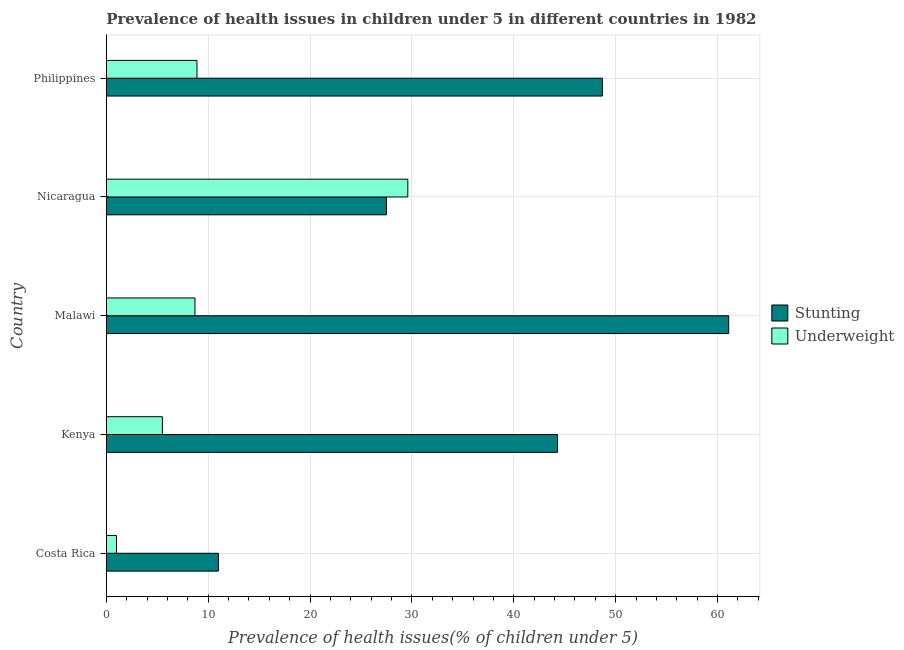How many different coloured bars are there?
Your answer should be very brief. 2. How many groups of bars are there?
Give a very brief answer. 5. Are the number of bars per tick equal to the number of legend labels?
Provide a succinct answer. Yes. Are the number of bars on each tick of the Y-axis equal?
Provide a succinct answer. Yes. How many bars are there on the 5th tick from the top?
Offer a very short reply. 2. What is the label of the 1st group of bars from the top?
Keep it short and to the point. Philippines. In how many cases, is the number of bars for a given country not equal to the number of legend labels?
Your answer should be very brief. 0. What is the percentage of stunted children in Philippines?
Provide a short and direct response. 48.7. Across all countries, what is the maximum percentage of stunted children?
Give a very brief answer. 61.1. In which country was the percentage of stunted children maximum?
Provide a short and direct response. Malawi. What is the total percentage of underweight children in the graph?
Give a very brief answer. 53.7. What is the difference between the percentage of underweight children in Costa Rica and that in Nicaragua?
Your response must be concise. -28.6. What is the average percentage of stunted children per country?
Give a very brief answer. 38.52. What is the difference between the percentage of stunted children and percentage of underweight children in Costa Rica?
Provide a succinct answer. 10. In how many countries, is the percentage of underweight children greater than 10 %?
Provide a short and direct response. 1. What is the ratio of the percentage of underweight children in Malawi to that in Nicaragua?
Provide a short and direct response. 0.29. Is the percentage of stunted children in Costa Rica less than that in Malawi?
Your answer should be very brief. Yes. What is the difference between the highest and the second highest percentage of stunted children?
Make the answer very short. 12.4. What is the difference between the highest and the lowest percentage of stunted children?
Provide a short and direct response. 50.1. Is the sum of the percentage of stunted children in Malawi and Philippines greater than the maximum percentage of underweight children across all countries?
Make the answer very short. Yes. What does the 1st bar from the top in Costa Rica represents?
Provide a succinct answer. Underweight. What does the 1st bar from the bottom in Philippines represents?
Offer a very short reply. Stunting. What is the difference between two consecutive major ticks on the X-axis?
Provide a succinct answer. 10. Are the values on the major ticks of X-axis written in scientific E-notation?
Keep it short and to the point. No. How many legend labels are there?
Make the answer very short. 2. How are the legend labels stacked?
Ensure brevity in your answer.  Vertical. What is the title of the graph?
Make the answer very short. Prevalence of health issues in children under 5 in different countries in 1982. What is the label or title of the X-axis?
Offer a very short reply. Prevalence of health issues(% of children under 5). What is the Prevalence of health issues(% of children under 5) in Stunting in Costa Rica?
Your response must be concise. 11. What is the Prevalence of health issues(% of children under 5) in Stunting in Kenya?
Your answer should be very brief. 44.3. What is the Prevalence of health issues(% of children under 5) of Underweight in Kenya?
Offer a terse response. 5.5. What is the Prevalence of health issues(% of children under 5) of Stunting in Malawi?
Ensure brevity in your answer.  61.1. What is the Prevalence of health issues(% of children under 5) in Underweight in Malawi?
Your answer should be very brief. 8.7. What is the Prevalence of health issues(% of children under 5) in Underweight in Nicaragua?
Keep it short and to the point. 29.6. What is the Prevalence of health issues(% of children under 5) in Stunting in Philippines?
Make the answer very short. 48.7. What is the Prevalence of health issues(% of children under 5) of Underweight in Philippines?
Give a very brief answer. 8.9. Across all countries, what is the maximum Prevalence of health issues(% of children under 5) in Stunting?
Ensure brevity in your answer.  61.1. Across all countries, what is the maximum Prevalence of health issues(% of children under 5) of Underweight?
Offer a terse response. 29.6. Across all countries, what is the minimum Prevalence of health issues(% of children under 5) of Stunting?
Your response must be concise. 11. What is the total Prevalence of health issues(% of children under 5) of Stunting in the graph?
Offer a very short reply. 192.6. What is the total Prevalence of health issues(% of children under 5) of Underweight in the graph?
Provide a short and direct response. 53.7. What is the difference between the Prevalence of health issues(% of children under 5) in Stunting in Costa Rica and that in Kenya?
Your answer should be compact. -33.3. What is the difference between the Prevalence of health issues(% of children under 5) in Stunting in Costa Rica and that in Malawi?
Your answer should be compact. -50.1. What is the difference between the Prevalence of health issues(% of children under 5) of Underweight in Costa Rica and that in Malawi?
Provide a succinct answer. -7.7. What is the difference between the Prevalence of health issues(% of children under 5) in Stunting in Costa Rica and that in Nicaragua?
Your response must be concise. -16.5. What is the difference between the Prevalence of health issues(% of children under 5) of Underweight in Costa Rica and that in Nicaragua?
Provide a short and direct response. -28.6. What is the difference between the Prevalence of health issues(% of children under 5) in Stunting in Costa Rica and that in Philippines?
Provide a succinct answer. -37.7. What is the difference between the Prevalence of health issues(% of children under 5) of Underweight in Costa Rica and that in Philippines?
Offer a terse response. -7.9. What is the difference between the Prevalence of health issues(% of children under 5) of Stunting in Kenya and that in Malawi?
Provide a succinct answer. -16.8. What is the difference between the Prevalence of health issues(% of children under 5) of Underweight in Kenya and that in Malawi?
Your response must be concise. -3.2. What is the difference between the Prevalence of health issues(% of children under 5) of Stunting in Kenya and that in Nicaragua?
Your response must be concise. 16.8. What is the difference between the Prevalence of health issues(% of children under 5) of Underweight in Kenya and that in Nicaragua?
Keep it short and to the point. -24.1. What is the difference between the Prevalence of health issues(% of children under 5) of Stunting in Malawi and that in Nicaragua?
Give a very brief answer. 33.6. What is the difference between the Prevalence of health issues(% of children under 5) in Underweight in Malawi and that in Nicaragua?
Offer a terse response. -20.9. What is the difference between the Prevalence of health issues(% of children under 5) in Stunting in Nicaragua and that in Philippines?
Give a very brief answer. -21.2. What is the difference between the Prevalence of health issues(% of children under 5) in Underweight in Nicaragua and that in Philippines?
Offer a terse response. 20.7. What is the difference between the Prevalence of health issues(% of children under 5) of Stunting in Costa Rica and the Prevalence of health issues(% of children under 5) of Underweight in Kenya?
Provide a short and direct response. 5.5. What is the difference between the Prevalence of health issues(% of children under 5) in Stunting in Costa Rica and the Prevalence of health issues(% of children under 5) in Underweight in Malawi?
Offer a terse response. 2.3. What is the difference between the Prevalence of health issues(% of children under 5) of Stunting in Costa Rica and the Prevalence of health issues(% of children under 5) of Underweight in Nicaragua?
Give a very brief answer. -18.6. What is the difference between the Prevalence of health issues(% of children under 5) of Stunting in Kenya and the Prevalence of health issues(% of children under 5) of Underweight in Malawi?
Keep it short and to the point. 35.6. What is the difference between the Prevalence of health issues(% of children under 5) in Stunting in Kenya and the Prevalence of health issues(% of children under 5) in Underweight in Nicaragua?
Offer a terse response. 14.7. What is the difference between the Prevalence of health issues(% of children under 5) in Stunting in Kenya and the Prevalence of health issues(% of children under 5) in Underweight in Philippines?
Your answer should be compact. 35.4. What is the difference between the Prevalence of health issues(% of children under 5) in Stunting in Malawi and the Prevalence of health issues(% of children under 5) in Underweight in Nicaragua?
Your response must be concise. 31.5. What is the difference between the Prevalence of health issues(% of children under 5) of Stunting in Malawi and the Prevalence of health issues(% of children under 5) of Underweight in Philippines?
Your response must be concise. 52.2. What is the difference between the Prevalence of health issues(% of children under 5) in Stunting in Nicaragua and the Prevalence of health issues(% of children under 5) in Underweight in Philippines?
Keep it short and to the point. 18.6. What is the average Prevalence of health issues(% of children under 5) of Stunting per country?
Keep it short and to the point. 38.52. What is the average Prevalence of health issues(% of children under 5) of Underweight per country?
Your answer should be very brief. 10.74. What is the difference between the Prevalence of health issues(% of children under 5) in Stunting and Prevalence of health issues(% of children under 5) in Underweight in Kenya?
Your response must be concise. 38.8. What is the difference between the Prevalence of health issues(% of children under 5) of Stunting and Prevalence of health issues(% of children under 5) of Underweight in Malawi?
Provide a short and direct response. 52.4. What is the difference between the Prevalence of health issues(% of children under 5) in Stunting and Prevalence of health issues(% of children under 5) in Underweight in Philippines?
Your response must be concise. 39.8. What is the ratio of the Prevalence of health issues(% of children under 5) of Stunting in Costa Rica to that in Kenya?
Give a very brief answer. 0.25. What is the ratio of the Prevalence of health issues(% of children under 5) in Underweight in Costa Rica to that in Kenya?
Your answer should be compact. 0.18. What is the ratio of the Prevalence of health issues(% of children under 5) in Stunting in Costa Rica to that in Malawi?
Provide a short and direct response. 0.18. What is the ratio of the Prevalence of health issues(% of children under 5) of Underweight in Costa Rica to that in Malawi?
Provide a succinct answer. 0.11. What is the ratio of the Prevalence of health issues(% of children under 5) in Stunting in Costa Rica to that in Nicaragua?
Provide a short and direct response. 0.4. What is the ratio of the Prevalence of health issues(% of children under 5) of Underweight in Costa Rica to that in Nicaragua?
Provide a succinct answer. 0.03. What is the ratio of the Prevalence of health issues(% of children under 5) in Stunting in Costa Rica to that in Philippines?
Offer a very short reply. 0.23. What is the ratio of the Prevalence of health issues(% of children under 5) in Underweight in Costa Rica to that in Philippines?
Offer a very short reply. 0.11. What is the ratio of the Prevalence of health issues(% of children under 5) in Stunting in Kenya to that in Malawi?
Your answer should be compact. 0.72. What is the ratio of the Prevalence of health issues(% of children under 5) of Underweight in Kenya to that in Malawi?
Provide a succinct answer. 0.63. What is the ratio of the Prevalence of health issues(% of children under 5) in Stunting in Kenya to that in Nicaragua?
Offer a very short reply. 1.61. What is the ratio of the Prevalence of health issues(% of children under 5) in Underweight in Kenya to that in Nicaragua?
Make the answer very short. 0.19. What is the ratio of the Prevalence of health issues(% of children under 5) in Stunting in Kenya to that in Philippines?
Make the answer very short. 0.91. What is the ratio of the Prevalence of health issues(% of children under 5) in Underweight in Kenya to that in Philippines?
Ensure brevity in your answer.  0.62. What is the ratio of the Prevalence of health issues(% of children under 5) of Stunting in Malawi to that in Nicaragua?
Your answer should be very brief. 2.22. What is the ratio of the Prevalence of health issues(% of children under 5) in Underweight in Malawi to that in Nicaragua?
Offer a terse response. 0.29. What is the ratio of the Prevalence of health issues(% of children under 5) in Stunting in Malawi to that in Philippines?
Ensure brevity in your answer.  1.25. What is the ratio of the Prevalence of health issues(% of children under 5) of Underweight in Malawi to that in Philippines?
Provide a succinct answer. 0.98. What is the ratio of the Prevalence of health issues(% of children under 5) in Stunting in Nicaragua to that in Philippines?
Your response must be concise. 0.56. What is the ratio of the Prevalence of health issues(% of children under 5) in Underweight in Nicaragua to that in Philippines?
Keep it short and to the point. 3.33. What is the difference between the highest and the second highest Prevalence of health issues(% of children under 5) of Underweight?
Offer a very short reply. 20.7. What is the difference between the highest and the lowest Prevalence of health issues(% of children under 5) of Stunting?
Provide a short and direct response. 50.1. What is the difference between the highest and the lowest Prevalence of health issues(% of children under 5) of Underweight?
Give a very brief answer. 28.6. 